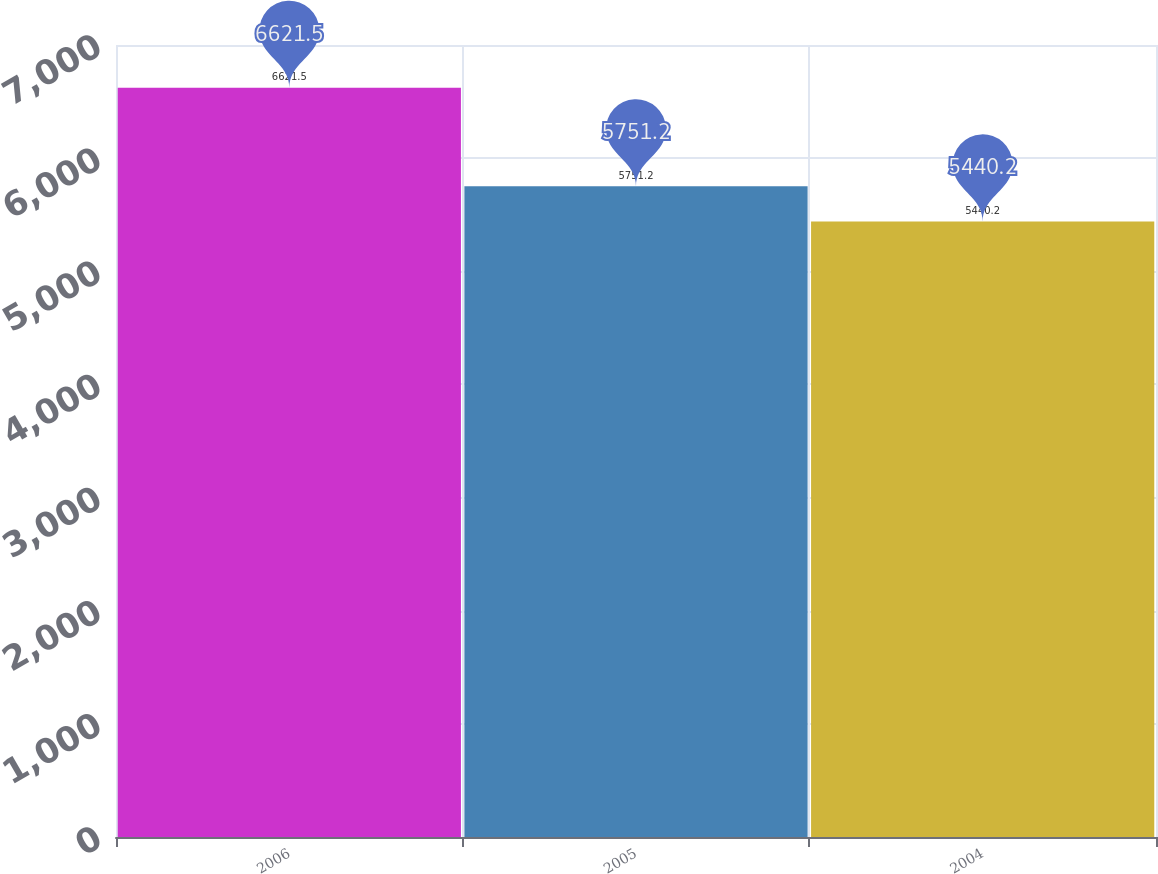Convert chart to OTSL. <chart><loc_0><loc_0><loc_500><loc_500><bar_chart><fcel>2006<fcel>2005<fcel>2004<nl><fcel>6621.5<fcel>5751.2<fcel>5440.2<nl></chart> 